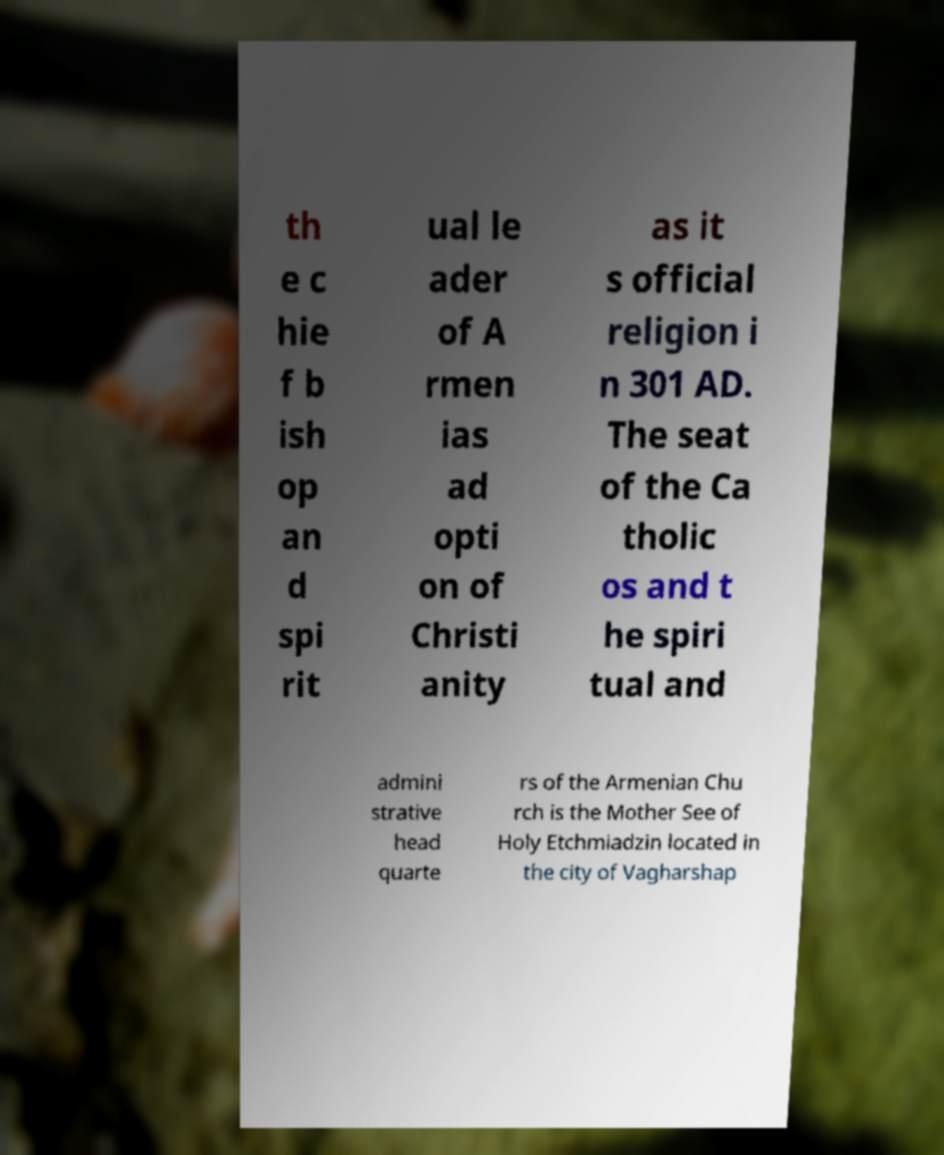Could you assist in decoding the text presented in this image and type it out clearly? th e c hie f b ish op an d spi rit ual le ader of A rmen ias ad opti on of Christi anity as it s official religion i n 301 AD. The seat of the Ca tholic os and t he spiri tual and admini strative head quarte rs of the Armenian Chu rch is the Mother See of Holy Etchmiadzin located in the city of Vagharshap 